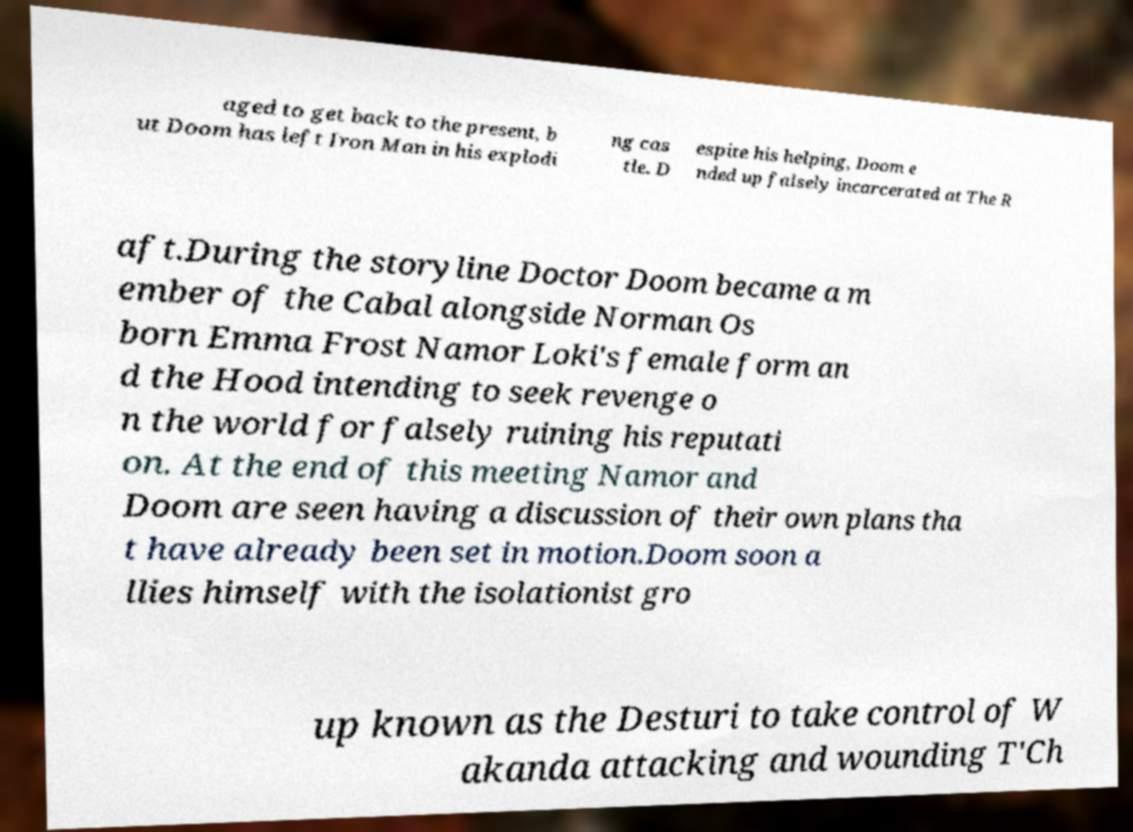Please read and relay the text visible in this image. What does it say? aged to get back to the present, b ut Doom has left Iron Man in his explodi ng cas tle. D espite his helping, Doom e nded up falsely incarcerated at The R aft.During the storyline Doctor Doom became a m ember of the Cabal alongside Norman Os born Emma Frost Namor Loki's female form an d the Hood intending to seek revenge o n the world for falsely ruining his reputati on. At the end of this meeting Namor and Doom are seen having a discussion of their own plans tha t have already been set in motion.Doom soon a llies himself with the isolationist gro up known as the Desturi to take control of W akanda attacking and wounding T'Ch 